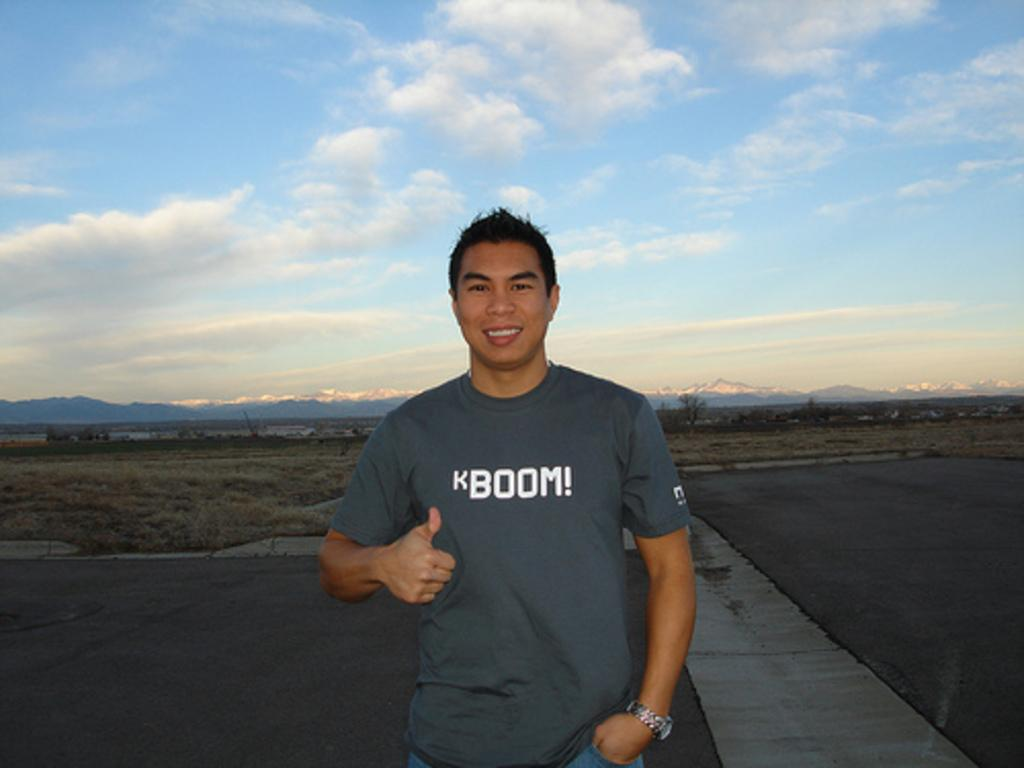What is the person in the image doing? The person is standing on the road in the image. What can be seen in the background of the image? There are trees, plants, grass, hills, and the sky visible in the background of the image. What is the condition of the sky in the image? The sky is visible in the background of the image, and there are clouds present. What type of shirt is the fish wearing in the image? There is no fish present in the image, and therefore no shirt or any other clothing item can be observed. 